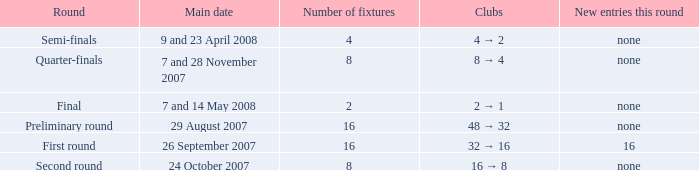What is the sum of Number of fixtures when the rounds shows quarter-finals? 8.0. 